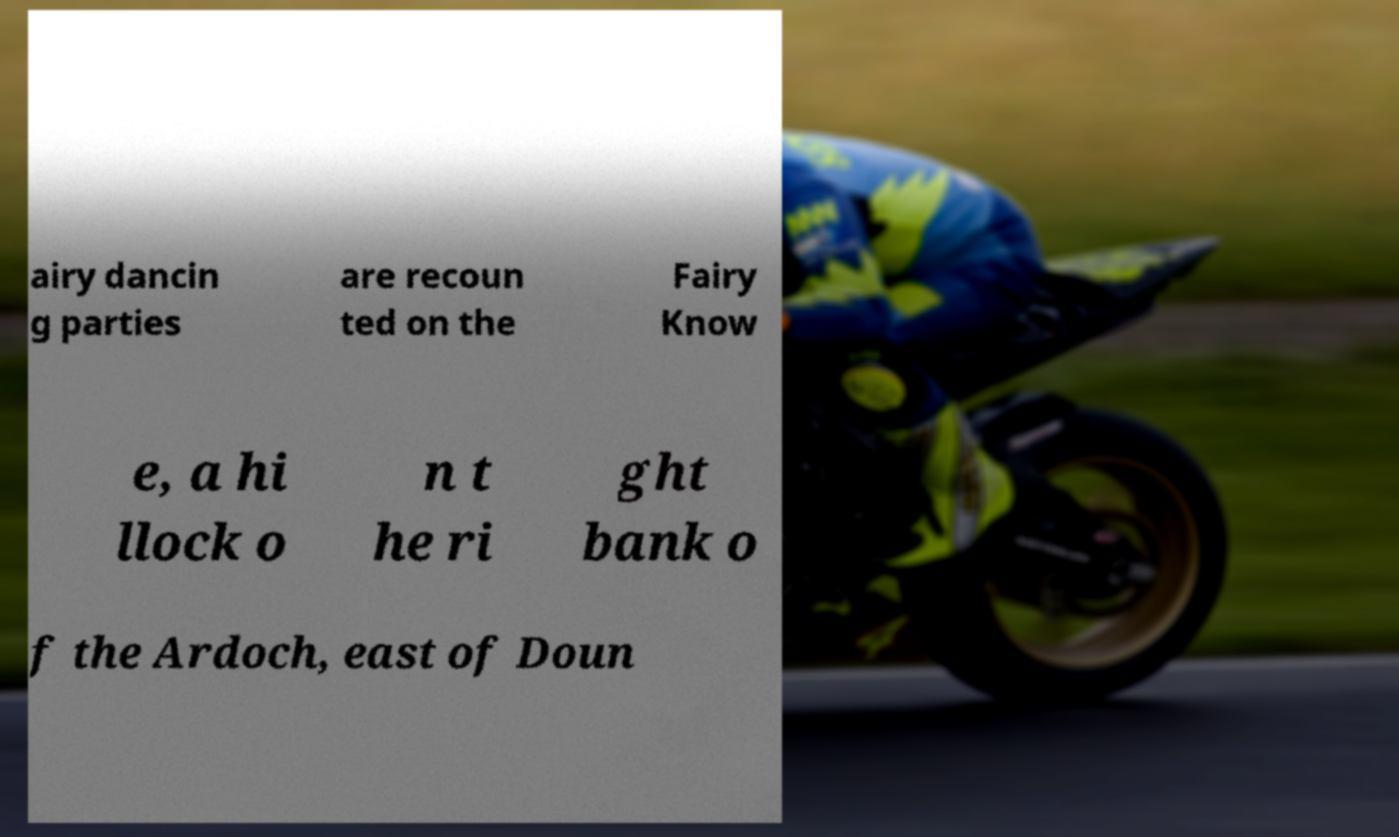I need the written content from this picture converted into text. Can you do that? airy dancin g parties are recoun ted on the Fairy Know e, a hi llock o n t he ri ght bank o f the Ardoch, east of Doun 